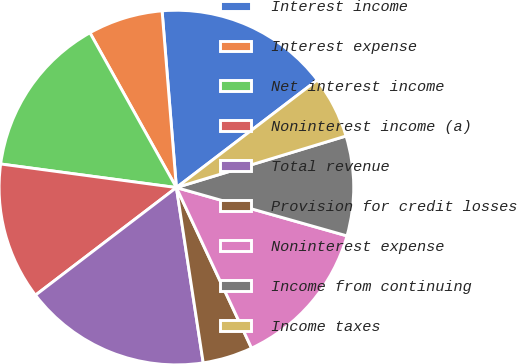Convert chart to OTSL. <chart><loc_0><loc_0><loc_500><loc_500><pie_chart><fcel>Interest income<fcel>Interest expense<fcel>Net interest income<fcel>Noninterest income (a)<fcel>Total revenue<fcel>Provision for credit losses<fcel>Noninterest expense<fcel>Income from continuing<fcel>Income taxes<nl><fcel>15.91%<fcel>6.82%<fcel>14.77%<fcel>12.5%<fcel>17.04%<fcel>4.55%<fcel>13.64%<fcel>9.09%<fcel>5.68%<nl></chart> 